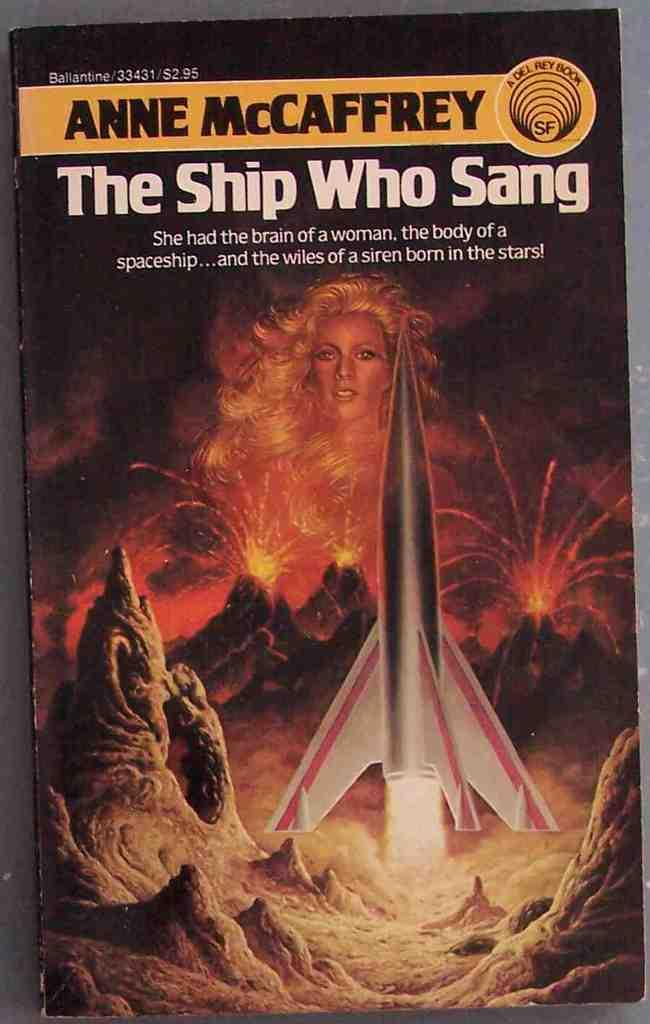<image>
Share a concise interpretation of the image provided. a book with the title of The Ship Who Sang 